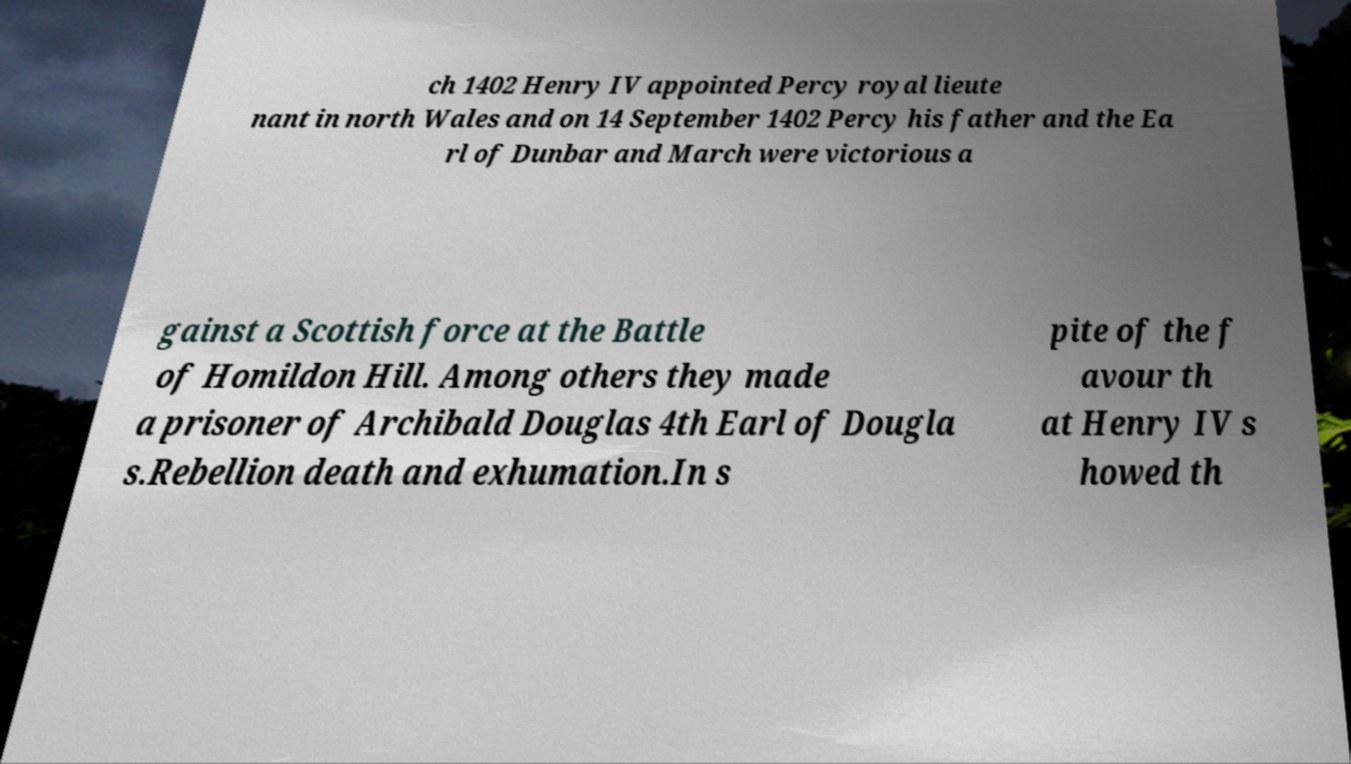Please identify and transcribe the text found in this image. ch 1402 Henry IV appointed Percy royal lieute nant in north Wales and on 14 September 1402 Percy his father and the Ea rl of Dunbar and March were victorious a gainst a Scottish force at the Battle of Homildon Hill. Among others they made a prisoner of Archibald Douglas 4th Earl of Dougla s.Rebellion death and exhumation.In s pite of the f avour th at Henry IV s howed th 